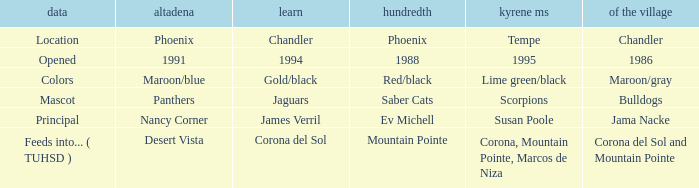Which Centennial has a Altadeña of panthers? Saber Cats. 